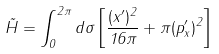Convert formula to latex. <formula><loc_0><loc_0><loc_500><loc_500>\tilde { H } = \int _ { 0 } ^ { 2 \pi } d \sigma \left [ \frac { ( x ^ { \prime } ) ^ { 2 } } { 1 6 \pi } + \pi ( p _ { x } ^ { \prime } ) ^ { 2 } \right ]</formula> 